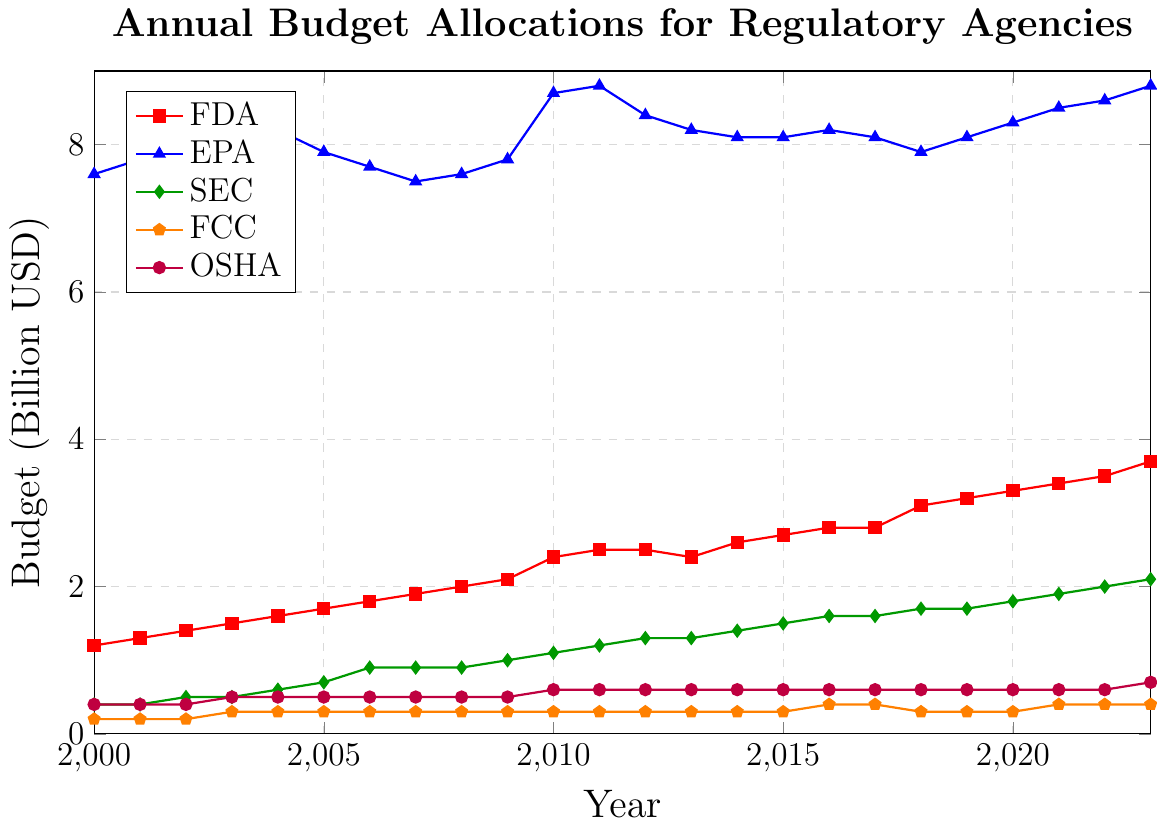What was the budget allocation for the SEC in 2020? Looking at the line corresponding to the SEC from 2020 on the x-axis, the budget value aligns with 1.8 on the y-axis.
Answer: 1.8 billion USD Which agency had the highest budget allocation in 2015? Comparing the heights of the lines in 2015 for all agencies, EPA has the tallest line, indicating the highest budget.
Answer: EPA By how much did the OSHA budget increase from 2000 to 2023? The OSHA budget in 2000 was 0.4 billion USD, and in 2023, it was 0.7 billion USD. The increase is 0.7 - 0.4 = 0.3 billion USD.
Answer: 0.3 billion USD Which agency had the smallest budget allocation throughout the years 2000 to 2023? Observing the lines for all agencies from 2000 to 2023, the FCC line remains the lowest.
Answer: FCC What is the difference in the budget allocations between FDA and EPA in 2023? In 2023, the FDA budget was 3.7 billion USD, and the EPA budget was 8.8 billion USD. The difference is 8.8 - 3.7 = 5.1 billion USD.
Answer: 5.1 billion USD Between which consecutive years did the EPA's budget see the largest increase? Comparing the differences between each consecutive year for EPA, the largest increase is from 2009 to 2010 where it went from 7.8 to 8.7 billion USD, an increase of 0.9 billion USD.
Answer: 2009 to 2010 Which agency's budget remained the most stable (least changing) from 2000 to 2023? Observing the shifts in all the lines, the FCC's line shows the least variation, fluctuating minimally from 0.2 to 0.4 billion USD.
Answer: FCC What is the combined budget allocation for all agencies in 2010? Summing the budgets for each agency in 2010: FDA (2.4), EPA (8.7), SEC (1.1), FCC (0.3), OSHA (0.6). Total = 2.4 + 8.7 + 1.1 + 0.3 + 0.6 = 13.1 billion USD.
Answer: 13.1 billion USD Which year did the SEC's budget surpass 1.0 billion USD for the first time? Tracking the SEC line, it first crosses 1.0 billion USD in 2009.
Answer: 2009 